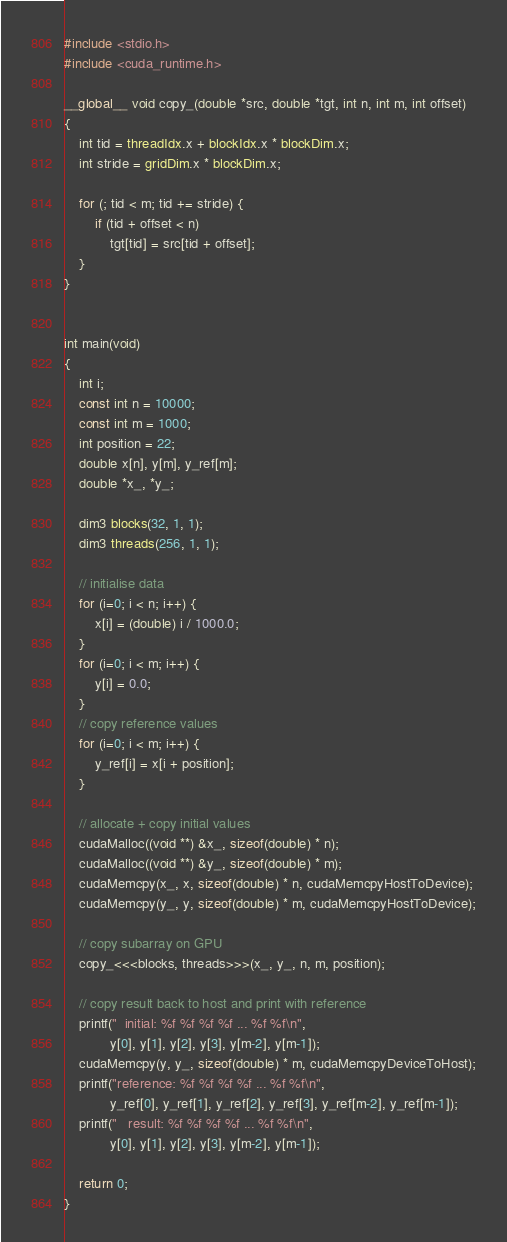<code> <loc_0><loc_0><loc_500><loc_500><_Cuda_>#include <stdio.h>
#include <cuda_runtime.h>

__global__ void copy_(double *src, double *tgt, int n, int m, int offset)
{
    int tid = threadIdx.x + blockIdx.x * blockDim.x;
    int stride = gridDim.x * blockDim.x;

    for (; tid < m; tid += stride) {
        if (tid + offset < n)
            tgt[tid] = src[tid + offset];
    }
}


int main(void)
{
    int i;
    const int n = 10000;
    const int m = 1000;
    int position = 22;
    double x[n], y[m], y_ref[m];
    double *x_, *y_;

    dim3 blocks(32, 1, 1);
    dim3 threads(256, 1, 1);

    // initialise data
    for (i=0; i < n; i++) {
        x[i] = (double) i / 1000.0;
    }
    for (i=0; i < m; i++) {
        y[i] = 0.0;
    }
    // copy reference values
    for (i=0; i < m; i++) {
        y_ref[i] = x[i + position];
    }

    // allocate + copy initial values
    cudaMalloc((void **) &x_, sizeof(double) * n);
    cudaMalloc((void **) &y_, sizeof(double) * m);
    cudaMemcpy(x_, x, sizeof(double) * n, cudaMemcpyHostToDevice);
    cudaMemcpy(y_, y, sizeof(double) * m, cudaMemcpyHostToDevice);

    // copy subarray on GPU
    copy_<<<blocks, threads>>>(x_, y_, n, m, position);

    // copy result back to host and print with reference
    printf("  initial: %f %f %f %f ... %f %f\n",
            y[0], y[1], y[2], y[3], y[m-2], y[m-1]);
    cudaMemcpy(y, y_, sizeof(double) * m, cudaMemcpyDeviceToHost);
    printf("reference: %f %f %f %f ... %f %f\n",
            y_ref[0], y_ref[1], y_ref[2], y_ref[3], y_ref[m-2], y_ref[m-1]);
    printf("   result: %f %f %f %f ... %f %f\n",
            y[0], y[1], y[2], y[3], y[m-2], y[m-1]);

    return 0;
}
</code> 